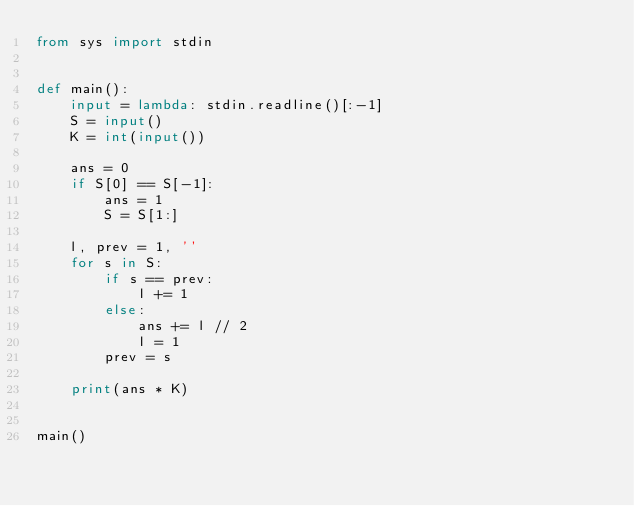Convert code to text. <code><loc_0><loc_0><loc_500><loc_500><_Python_>from sys import stdin


def main():
    input = lambda: stdin.readline()[:-1]
    S = input()
    K = int(input())

    ans = 0
    if S[0] == S[-1]:
        ans = 1
        S = S[1:]

    l, prev = 1, ''
    for s in S:
        if s == prev:
            l += 1
        else:
            ans += l // 2
            l = 1
        prev = s

    print(ans * K)


main()
</code> 